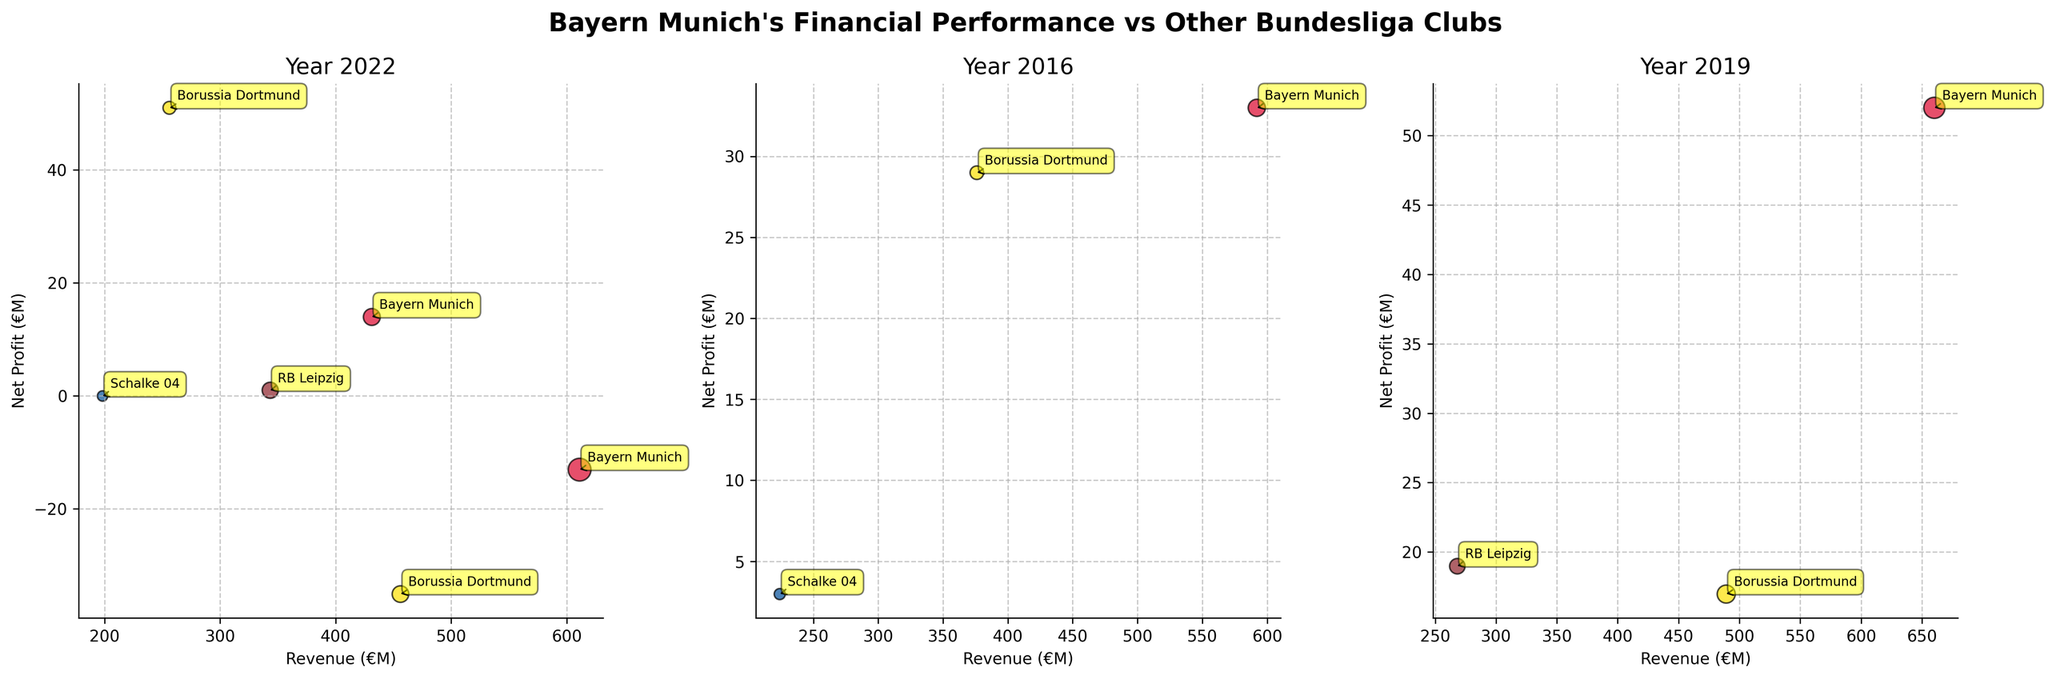How many Bundesliga clubs are represented in each subplot? By observing each subplot, we can see the unique clubs depicted by different bubbles. In all four subplots representing 2013, 2016, 2019, and 2022, there are three clubs each in 2013 and 2016 (Bayern Munich, Borussia Dortmund, Schalke 04). In 2019 and 2022, there are an additional club: RB Leipzig.
Answer: 3 in 2013 and 2016, 4 in 2019 and 2022 Which club had the highest revenue in 2019? In the subplot titled "Year 2019," the largest bubble by revenue belongs to Bayern Munich. This can also be derived by looking at the x-axis label for the far-right position of the bubble representing Bayern Munich.
Answer: Bayern Munich Which year did Bayern Munich have the lowest net profit? By examining the net profit indicated on the y-axis, we find the bubble representing Bayern Munich in 2022 is positioned below the x-axis, meaning it had a negative net profit. As it is the lowest point for Bayern Munich across the four subplots, we conclude that 2022 is the year with the lowest net profit for Bayern Munich.
Answer: 2022 Compare the market values of Bayern Munich and Borussia Dortmund in 2022. Which one is higher and by how much? In the subplot titled "Year 2022," the size of the bubble reflects market value. Bayern Munich's bubble is larger than Borussia Dortmund's. To quantify, Bayern Munich is indicated to have a market value of 1020€M and Borussia Dortmund of 540€M. The difference is 1020 - 540.
Answer: Bayern Munich, 480€M What was the net profit of Schalke 04 in 2013? Looking at the subplot titled "Year 2013," the bubble representing Schalke 04 touches the x-axis, indicating a net profit of zero.
Answer: 0 Which club showed an increase in both revenue and market value between 2013 and 2019? Observing the positions and sizes of the bubbles over the years, Bayern Munich shows both an increase in revenue (from 431€M in 2013 to 660€M in 2019) and market value (from 560€M in 2013 to 880€M in 2019).
Answer: Bayern Munich What trend can be observed in RB Leipzig's net profit from 2019 to 2022? From 2019 to 2022, RB Leipzig's bubble moves slightly upwards on the y-axis, indicating an increase in net profit (19€M in 2019 to 1€M in 2022). Although the net profit decreases, it remains positive.
Answer: Decreasing positive net profit Which club had a negative net profit in 2022 and what does it indicate? The subplots show two bubbles below the x-axis in 2022: Bayern Munich and Borussia Dortmund. This indicates both clubs had negative net profits that year.
Answer: Bayern Munich and Borussia Dortmund Comparing the net profits, which club performed best in 2013? The subplot labelled "Year 2013," reveals the highest bubble along the y-axis is for Borussia Dortmund, indicating the highest net profit.
Answer: Borussia Dortmund 